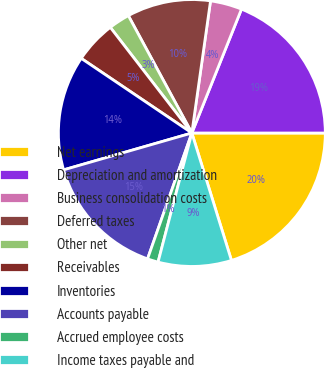Convert chart to OTSL. <chart><loc_0><loc_0><loc_500><loc_500><pie_chart><fcel>Net earnings<fcel>Depreciation and amortization<fcel>Business consolidation costs<fcel>Deferred taxes<fcel>Other net<fcel>Receivables<fcel>Inventories<fcel>Accounts payable<fcel>Accrued employee costs<fcel>Income taxes payable and<nl><fcel>20.2%<fcel>18.94%<fcel>3.83%<fcel>10.13%<fcel>2.57%<fcel>5.09%<fcel>13.9%<fcel>15.16%<fcel>1.31%<fcel>8.87%<nl></chart> 